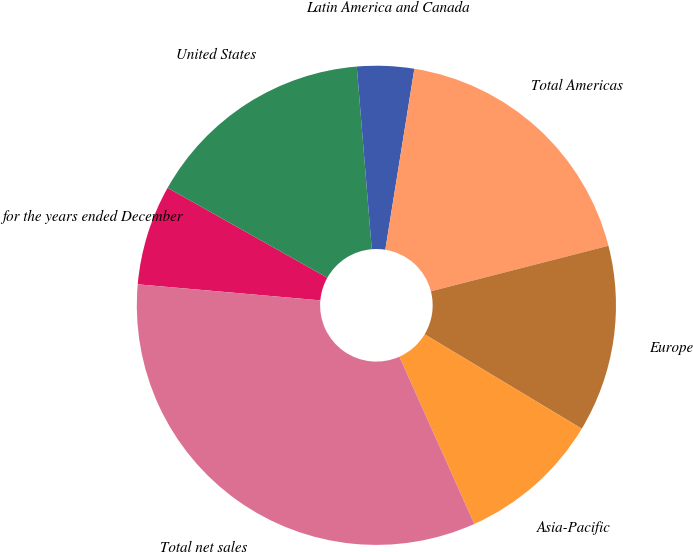Convert chart. <chart><loc_0><loc_0><loc_500><loc_500><pie_chart><fcel>for the years ended December<fcel>United States<fcel>Latin America and Canada<fcel>Total Americas<fcel>Europe<fcel>Asia-Pacific<fcel>Total net sales<nl><fcel>6.76%<fcel>15.54%<fcel>3.84%<fcel>18.47%<fcel>12.61%<fcel>9.69%<fcel>33.1%<nl></chart> 